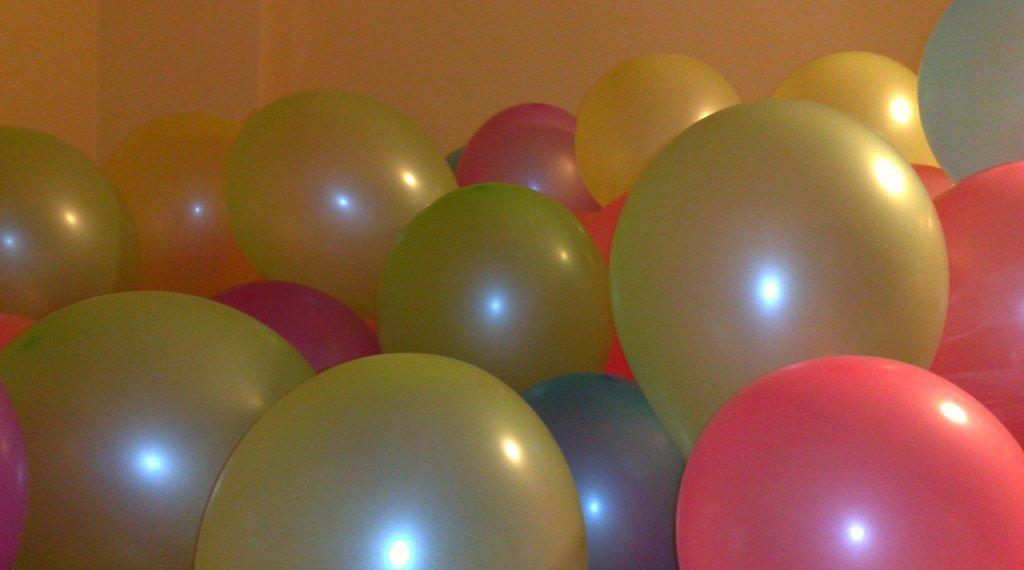What type of objects are present in the image? There are balloons of different colors in the image. What can be seen in the background of the image? There is a wall in the background of the image. How many mice are sitting on the table in the image? There are no mice or tables present in the image; it only features balloons and a wall in the background. 